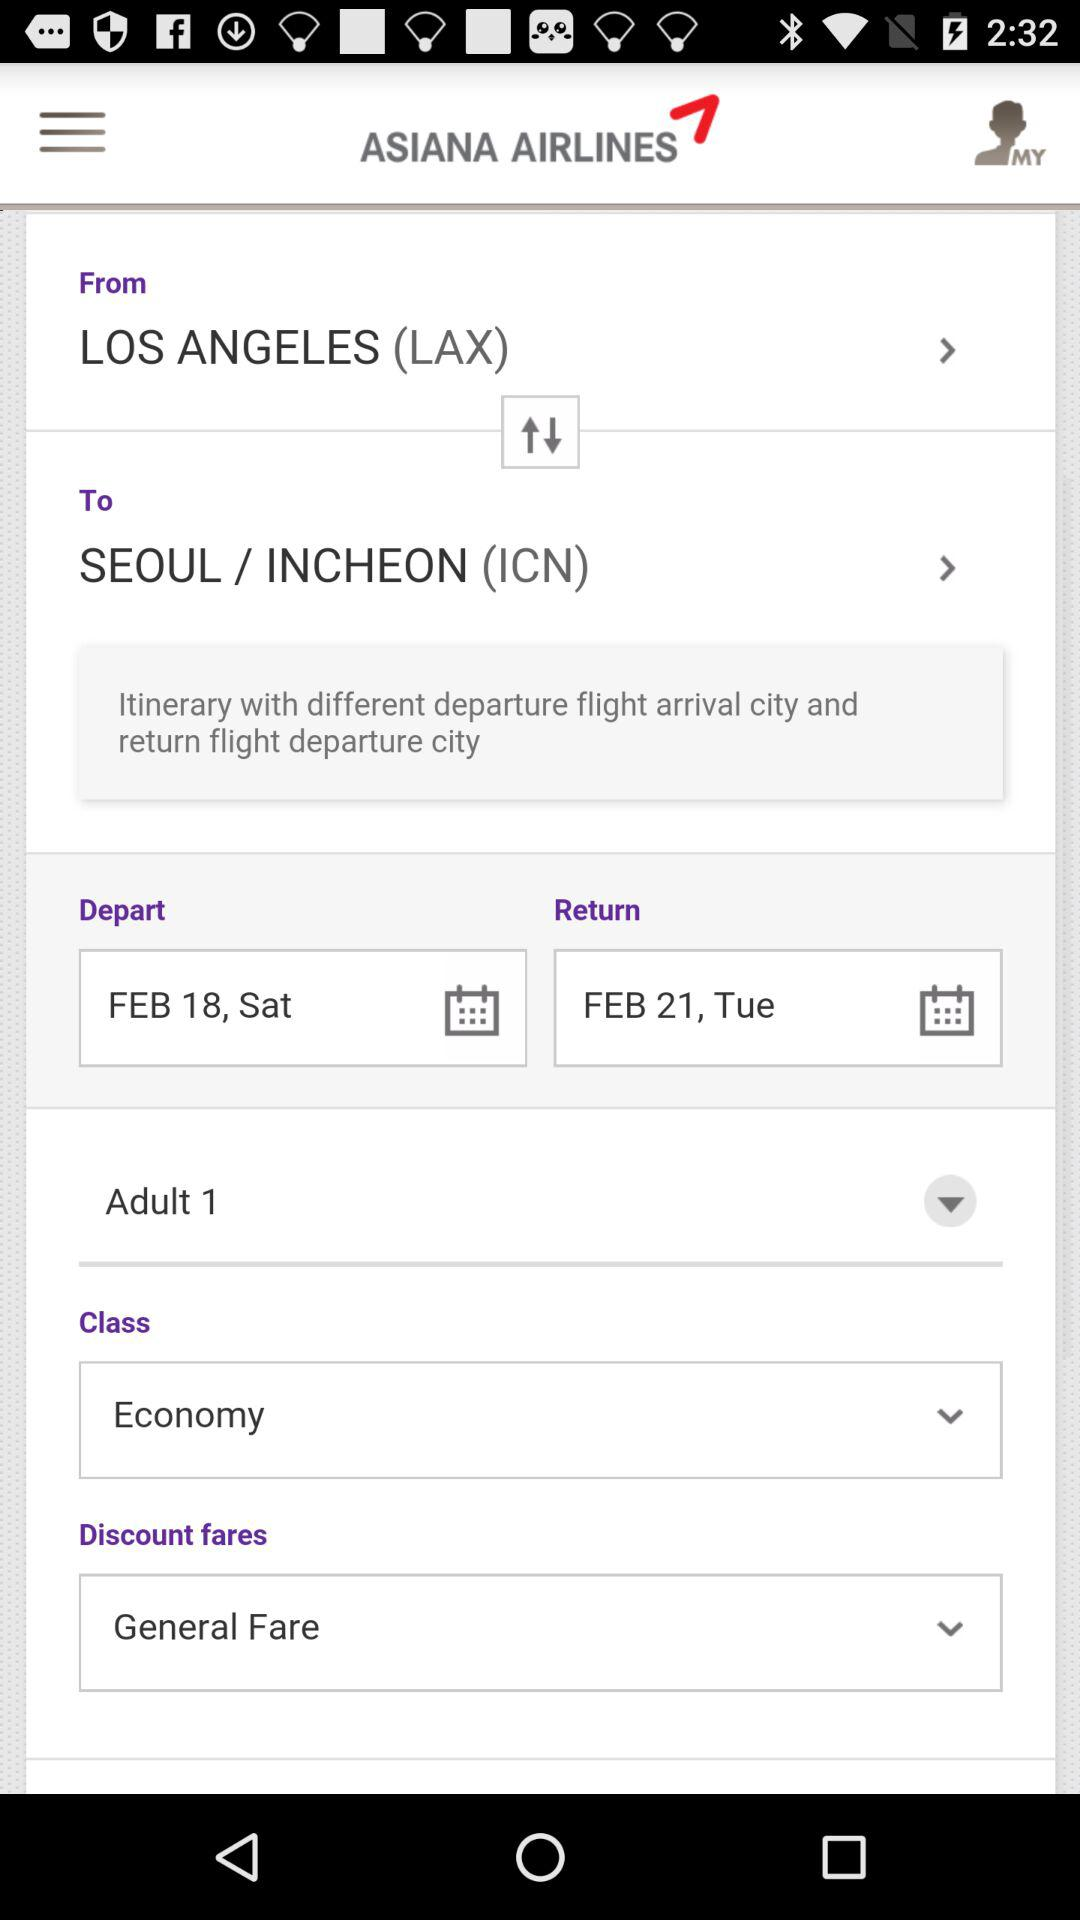What is the name of the airline? The name of the airline is Asiana Airlines. 